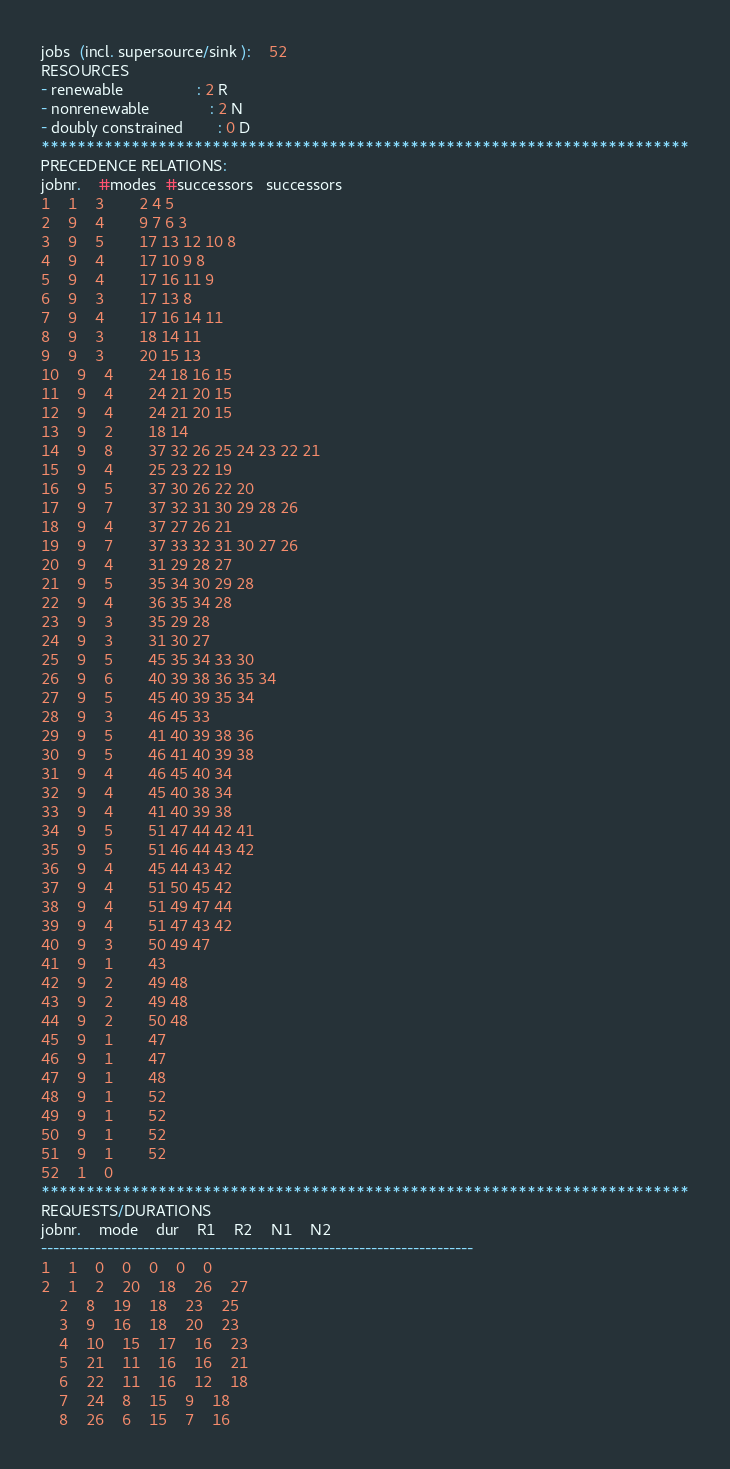Convert code to text. <code><loc_0><loc_0><loc_500><loc_500><_ObjectiveC_>jobs  (incl. supersource/sink ):	52
RESOURCES
- renewable                 : 2 R
- nonrenewable              : 2 N
- doubly constrained        : 0 D
************************************************************************
PRECEDENCE RELATIONS:
jobnr.    #modes  #successors   successors
1	1	3		2 4 5 
2	9	4		9 7 6 3 
3	9	5		17 13 12 10 8 
4	9	4		17 10 9 8 
5	9	4		17 16 11 9 
6	9	3		17 13 8 
7	9	4		17 16 14 11 
8	9	3		18 14 11 
9	9	3		20 15 13 
10	9	4		24 18 16 15 
11	9	4		24 21 20 15 
12	9	4		24 21 20 15 
13	9	2		18 14 
14	9	8		37 32 26 25 24 23 22 21 
15	9	4		25 23 22 19 
16	9	5		37 30 26 22 20 
17	9	7		37 32 31 30 29 28 26 
18	9	4		37 27 26 21 
19	9	7		37 33 32 31 30 27 26 
20	9	4		31 29 28 27 
21	9	5		35 34 30 29 28 
22	9	4		36 35 34 28 
23	9	3		35 29 28 
24	9	3		31 30 27 
25	9	5		45 35 34 33 30 
26	9	6		40 39 38 36 35 34 
27	9	5		45 40 39 35 34 
28	9	3		46 45 33 
29	9	5		41 40 39 38 36 
30	9	5		46 41 40 39 38 
31	9	4		46 45 40 34 
32	9	4		45 40 38 34 
33	9	4		41 40 39 38 
34	9	5		51 47 44 42 41 
35	9	5		51 46 44 43 42 
36	9	4		45 44 43 42 
37	9	4		51 50 45 42 
38	9	4		51 49 47 44 
39	9	4		51 47 43 42 
40	9	3		50 49 47 
41	9	1		43 
42	9	2		49 48 
43	9	2		49 48 
44	9	2		50 48 
45	9	1		47 
46	9	1		47 
47	9	1		48 
48	9	1		52 
49	9	1		52 
50	9	1		52 
51	9	1		52 
52	1	0		
************************************************************************
REQUESTS/DURATIONS
jobnr.	mode	dur	R1	R2	N1	N2	
------------------------------------------------------------------------
1	1	0	0	0	0	0	
2	1	2	20	18	26	27	
	2	8	19	18	23	25	
	3	9	16	18	20	23	
	4	10	15	17	16	23	
	5	21	11	16	16	21	
	6	22	11	16	12	18	
	7	24	8	15	9	18	
	8	26	6	15	7	16	</code> 